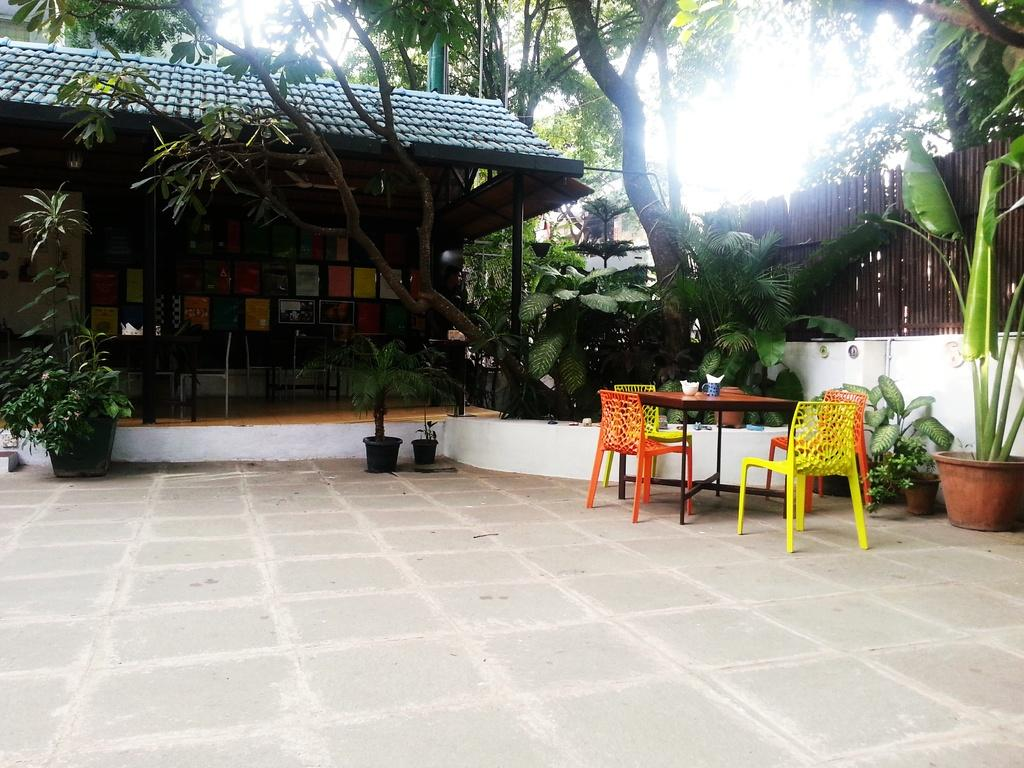What type of structure is visible in the image? There is a house in the image. What natural elements can be seen in the image? There are trees and plants in the image. What type of containers are present in the image? There are pots in the image. What part of the natural environment is visible in the image? The sky is visible in the image. What type of furniture is in the image? There is a table and chairs in the image. What objects are on the table? There is a glass and a bowl on the table. How many clocks are hanging on the trees in the image? There are no clocks hanging on the trees in the image. What type of flag is being waved by the plants in the image? There are no flags present in the image, and the plants are not waving anything. 